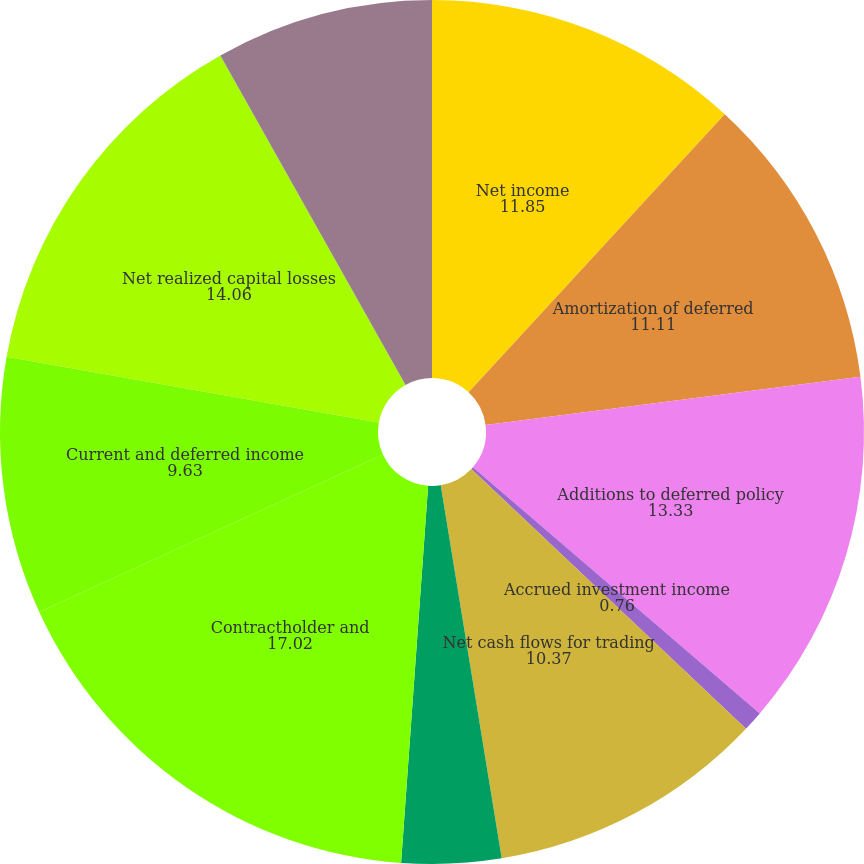<chart> <loc_0><loc_0><loc_500><loc_500><pie_chart><fcel>Net income<fcel>Amortization of deferred<fcel>Additions to deferred policy<fcel>Accrued investment income<fcel>Net cash flows for trading<fcel>Premiums due and other<fcel>Contractholder and<fcel>Current and deferred income<fcel>Net realized capital losses<fcel>Depreciation and amortization<nl><fcel>11.85%<fcel>11.11%<fcel>13.33%<fcel>0.76%<fcel>10.37%<fcel>3.72%<fcel>17.02%<fcel>9.63%<fcel>14.06%<fcel>8.15%<nl></chart> 